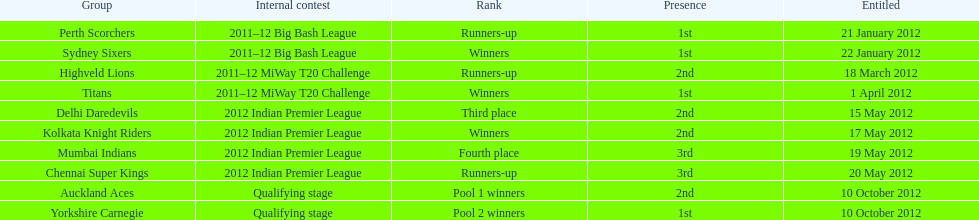Which team came in after the titans in the miway t20 challenge? Highveld Lions. 